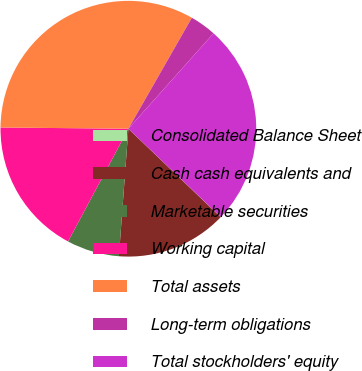<chart> <loc_0><loc_0><loc_500><loc_500><pie_chart><fcel>Consolidated Balance Sheet<fcel>Cash cash equivalents and<fcel>Marketable securities<fcel>Working capital<fcel>Total assets<fcel>Long-term obligations<fcel>Total stockholders' equity<nl><fcel>0.02%<fcel>14.02%<fcel>6.64%<fcel>17.33%<fcel>33.12%<fcel>3.33%<fcel>25.54%<nl></chart> 